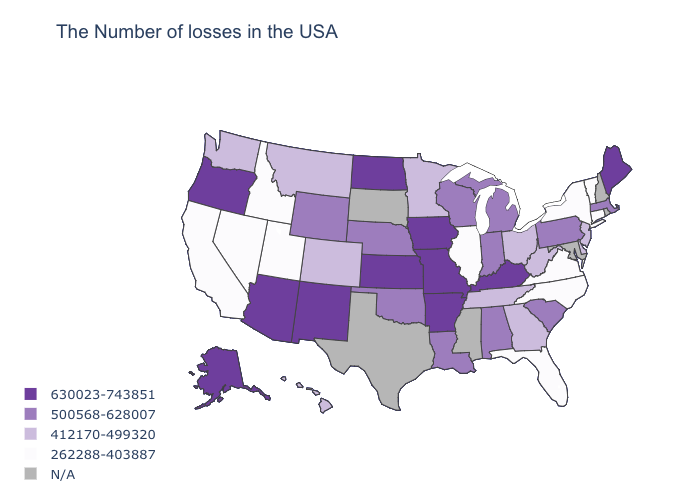What is the value of New Hampshire?
Keep it brief. N/A. Which states have the highest value in the USA?
Short answer required. Maine, Kentucky, Missouri, Arkansas, Iowa, Kansas, North Dakota, New Mexico, Arizona, Oregon, Alaska. Does the first symbol in the legend represent the smallest category?
Concise answer only. No. Does Maine have the lowest value in the Northeast?
Answer briefly. No. What is the value of New York?
Quick response, please. 262288-403887. Which states have the highest value in the USA?
Be succinct. Maine, Kentucky, Missouri, Arkansas, Iowa, Kansas, North Dakota, New Mexico, Arizona, Oregon, Alaska. What is the lowest value in the USA?
Quick response, please. 262288-403887. Does Illinois have the lowest value in the MidWest?
Keep it brief. Yes. Does Kentucky have the lowest value in the South?
Write a very short answer. No. What is the value of Delaware?
Write a very short answer. 412170-499320. Name the states that have a value in the range 412170-499320?
Concise answer only. New Jersey, Delaware, West Virginia, Ohio, Georgia, Tennessee, Minnesota, Colorado, Montana, Washington, Hawaii. Name the states that have a value in the range N/A?
Be succinct. Rhode Island, New Hampshire, Maryland, Mississippi, Texas, South Dakota. 